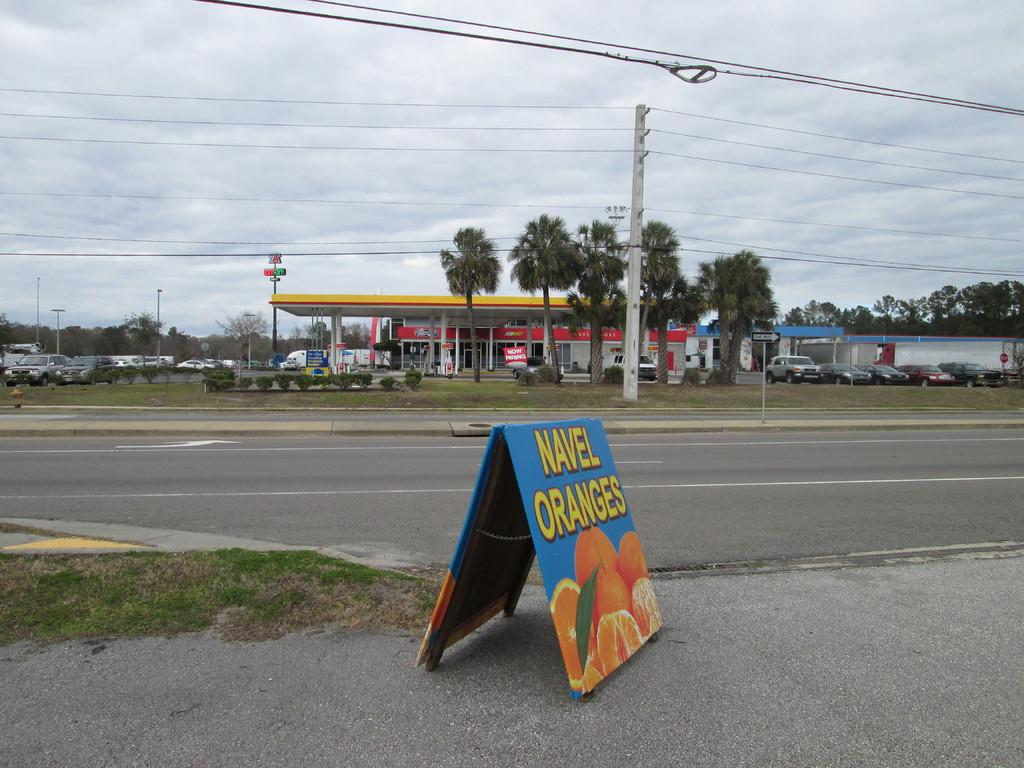<image>
Describe the image concisely. An add on the side of the street advertises navel oranges. 